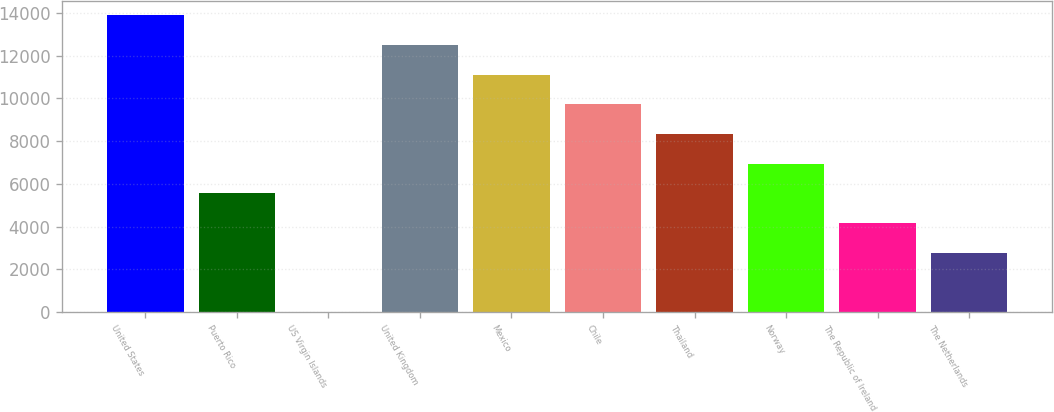Convert chart. <chart><loc_0><loc_0><loc_500><loc_500><bar_chart><fcel>United States<fcel>Puerto Rico<fcel>US Virgin Islands<fcel>United Kingdom<fcel>Mexico<fcel>Chile<fcel>Thailand<fcel>Norway<fcel>The Republic of Ireland<fcel>The Netherlands<nl><fcel>13882<fcel>5553.4<fcel>1<fcel>12493.9<fcel>11105.8<fcel>9717.7<fcel>8329.6<fcel>6941.5<fcel>4165.3<fcel>2777.2<nl></chart> 